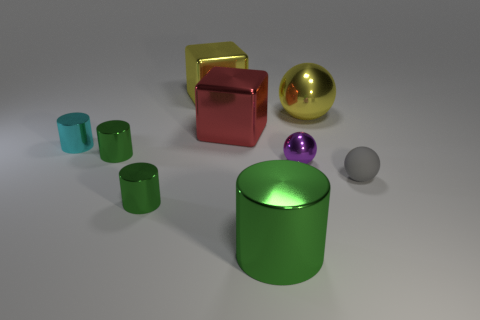Subtract all cyan cylinders. How many cylinders are left? 3 Subtract all small cylinders. How many cylinders are left? 1 Subtract 3 balls. How many balls are left? 0 Add 7 small green shiny cylinders. How many small green shiny cylinders exist? 9 Subtract 0 green blocks. How many objects are left? 9 Subtract all cylinders. How many objects are left? 5 Subtract all blue cubes. Subtract all gray balls. How many cubes are left? 2 Subtract all cyan blocks. How many purple spheres are left? 1 Subtract all tiny green objects. Subtract all large yellow metallic balls. How many objects are left? 6 Add 4 red shiny blocks. How many red shiny blocks are left? 5 